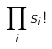Convert formula to latex. <formula><loc_0><loc_0><loc_500><loc_500>\prod _ { i } s _ { i } !</formula> 